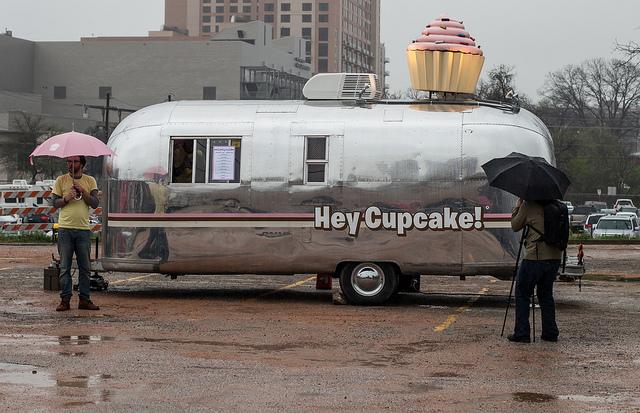What is on top of the truck?
Short answer required. Cupcake. Is this a food truck?
Write a very short answer. Yes. What is the name of the truck?
Concise answer only. Hey cupcake!. 